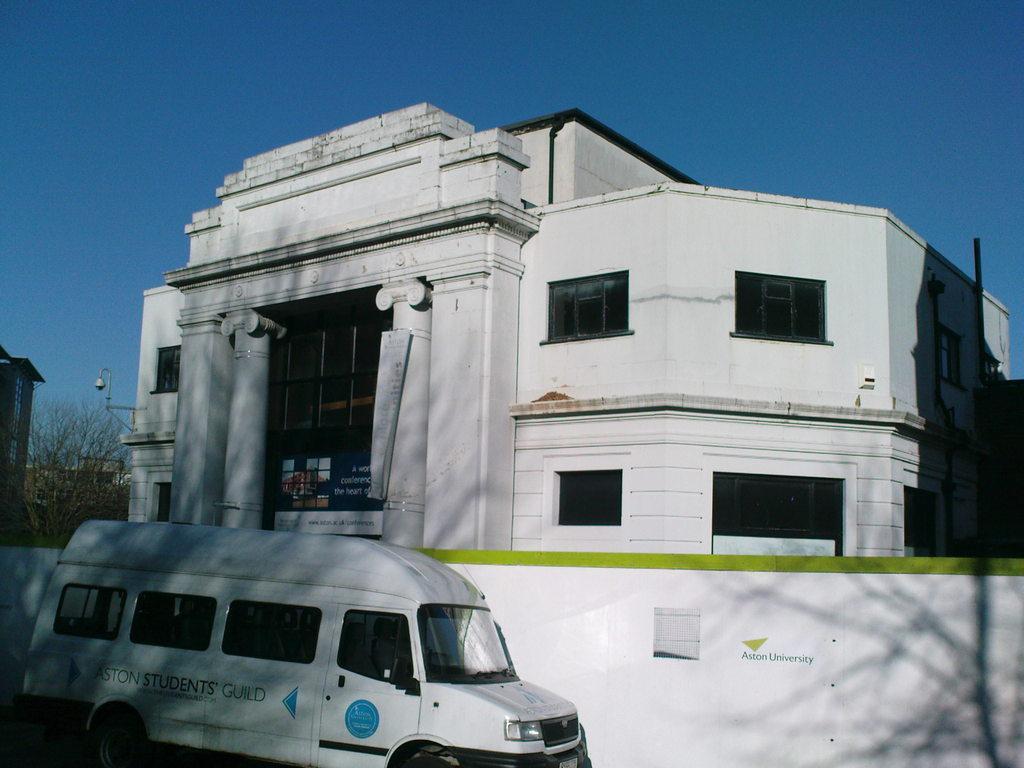How would you summarize this image in a sentence or two? In this image we can see a white color van. Behind the van, boundary wall is there. Behind the boundary wall, we can see building, light and tree. The sky is in blue color. 